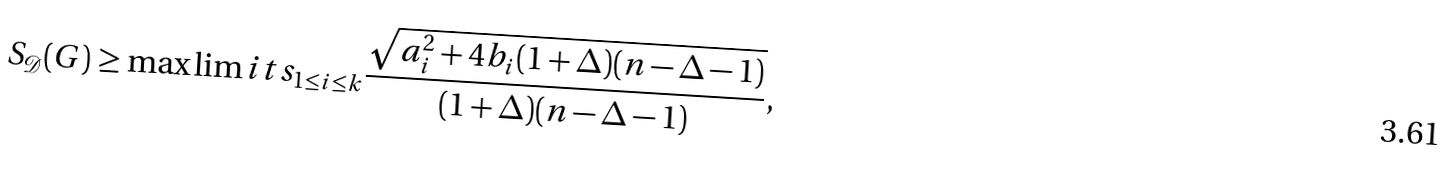Convert formula to latex. <formula><loc_0><loc_0><loc_500><loc_500>S _ { \mathcal { D } } ( G ) \geq \max \lim i t s _ { 1 \leq i \leq k } { \frac { \sqrt { a _ { i } ^ { 2 } + 4 b _ { i } ( 1 + \Delta ) ( n - \Delta - 1 ) } } { ( 1 + \Delta ) ( n - \Delta - 1 ) } } ,</formula> 